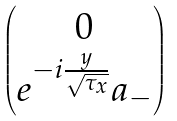Convert formula to latex. <formula><loc_0><loc_0><loc_500><loc_500>\begin{pmatrix} 0 \\ e ^ { - i \frac { y } { \sqrt { \tau _ { x } } } } a _ { - } \end{pmatrix}</formula> 